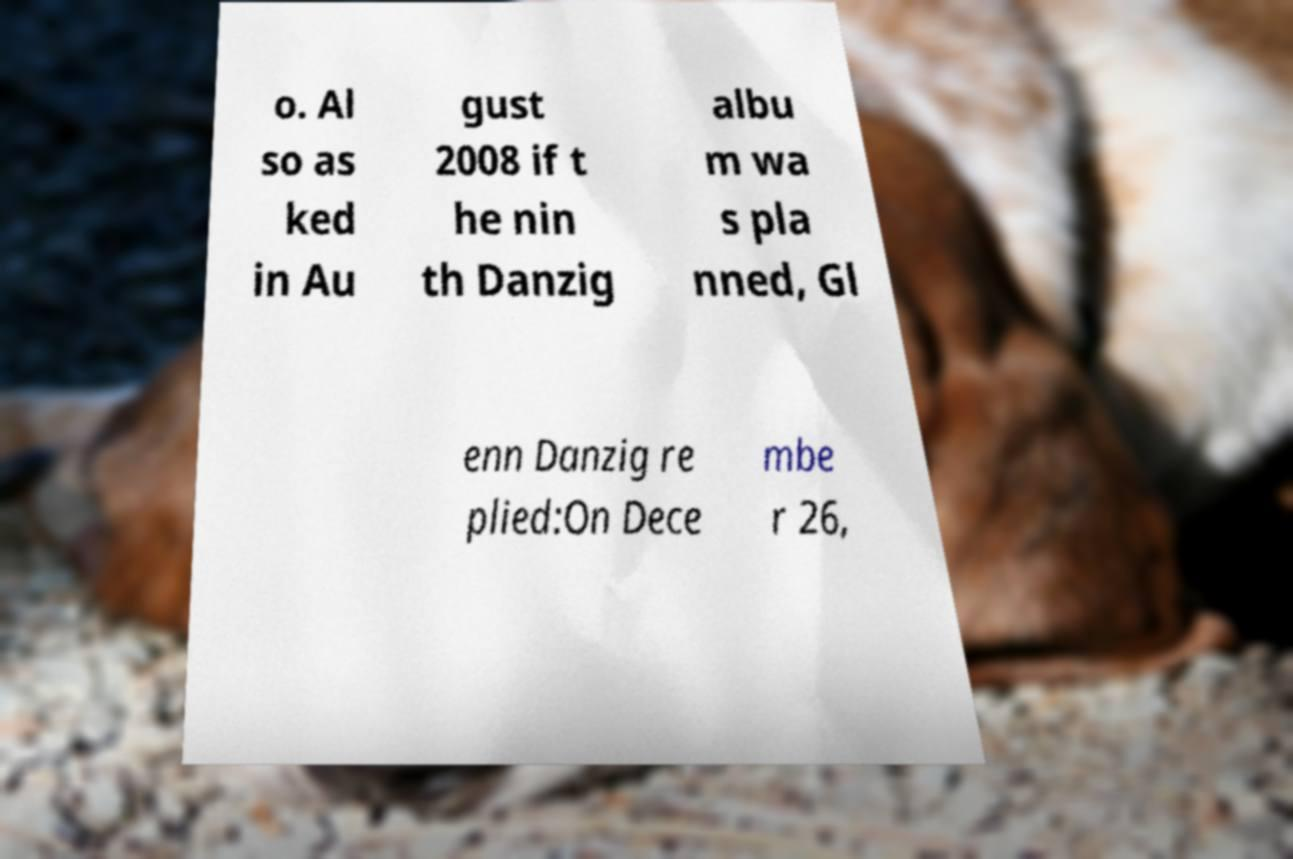Can you read and provide the text displayed in the image?This photo seems to have some interesting text. Can you extract and type it out for me? o. Al so as ked in Au gust 2008 if t he nin th Danzig albu m wa s pla nned, Gl enn Danzig re plied:On Dece mbe r 26, 